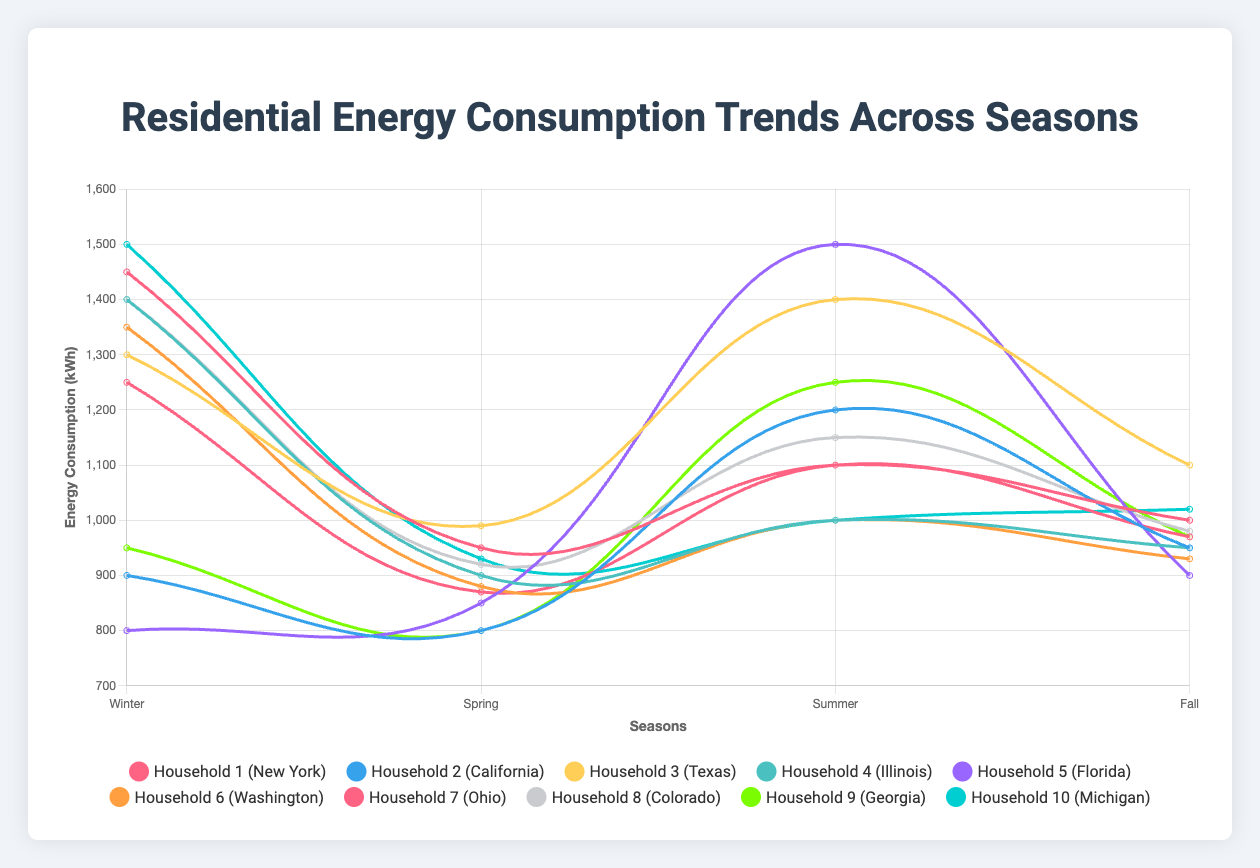What is the average energy consumption of Household 3 across all seasons? Household 3 in Texas has the following energy consumption: Winter (1300 kWh), Spring (990 kWh), Summer (1400 kWh), and Fall (1100 kWh). Adding these, we get 1300 + 990 + 1400 + 1100 = 4790 kWh. Dividing by 4 (number of seasons), the average is 4790 / 4 = 1197.5 kWh.
Answer: 1197.5 kWh Which household consumed the most energy in summer? To determine which household consumed the most energy in summer, we look for the highest summer consumption across all households. Comparing the summer consumption values: Household 1 (1100), Household 2 (1200), Household 3 (1400), Household 4 (1000), Household 5 (1500), Household 6 (1000), Household 7 (1100), Household 8 (1150), Household 9 (1250), Household 10 (1000), the highest is 1500 kWh by Household 5 in Florida.
Answer: Household 5 Compare the energy consumption in winter and summer for Household 7. Which season has higher consumption? Household 7 in Ohio has winter consumption of 1250 kWh and summer consumption of 1100 kWh. Comparing these two values, 1250 kWh (winter) is greater than 1100 kWh (summer).
Answer: Winter What is the total energy consumption for Household 10 across all seasons? Household 10 in Michigan has the following consumption: Winter (1500 kWh), Spring (930 kWh), Summer (1000 kWh), and Fall (1020 kWh). Adding these, we get 1500 + 930 + 1000 + 1020 = 4450 kWh.
Answer: 4450 kWh Which household in New York consumed less energy in Spring compared to Fall? Household 1 in New York has spring consumption of 950 kWh and fall consumption of 1000 kWh. Since 950 kWh (Spring) is less than 1000 kWh (Fall), Household 1 consumed less energy in Spring.
Answer: Household 1 Order the households based on their fall energy consumption from highest to lowest. Observing the fall consumption values: Household 1 (1000), Household 2 (950), Household 3 (1100), Household 4 (950), Household 5 (900), Household 6 (930), Household 7 (970), Household 8 (980), Household 9 (970), Household 10 (1020), the ordered list from highest to lowest is: Household 3 (1100), Household 10 (1020), Household 1 (1000), Household 8 (980), Household 7 (970), Household 9 (970), Household 6 (930), Household 2 (950), Household 4 (950), Household 5 (900).
Answer: Household 3, Household 10, Household 1, Household 8, Household 7, Household 9, Household 6, Household 2, Household 4, Household 5 How much more energy did Household 1 consume in Winter compared to Spring? Household 1 in New York consumed 1450 kWh in Winter and 950 kWh in Spring. The difference is 1450 - 950 = 500 kWh.
Answer: 500 kWh 